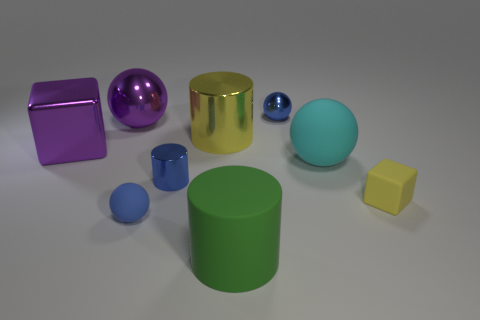Subtract all green cylinders. How many cylinders are left? 2 Subtract all metal cylinders. How many cylinders are left? 1 Add 1 cyan matte things. How many objects exist? 10 Subtract all spheres. How many objects are left? 5 Subtract 4 spheres. How many spheres are left? 0 Add 5 large cyan matte spheres. How many large cyan matte spheres exist? 6 Subtract 0 green cubes. How many objects are left? 9 Subtract all yellow cylinders. Subtract all red balls. How many cylinders are left? 2 Subtract all cyan balls. How many green cylinders are left? 1 Subtract all tiny blue rubber objects. Subtract all metallic cubes. How many objects are left? 7 